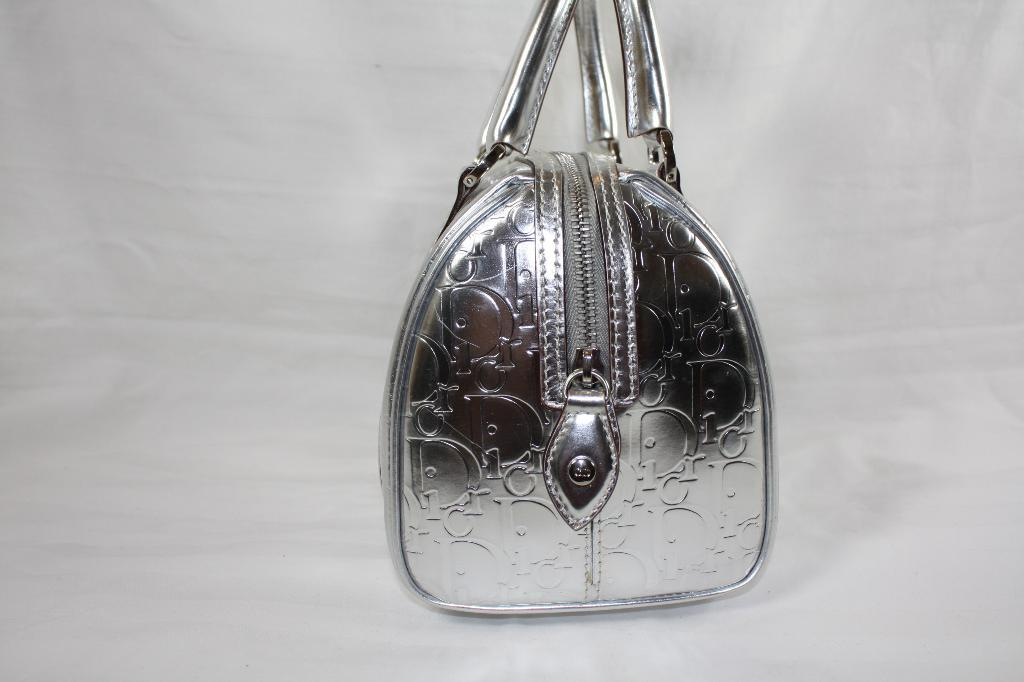What type of accessory is present in the image? There is a handbag in the image. What color is the handbag? The handbag is silver in color. What type of bread is being used to hold the receipt in the image? There is no bread or receipt present in the image; it only features a silver handbag. 